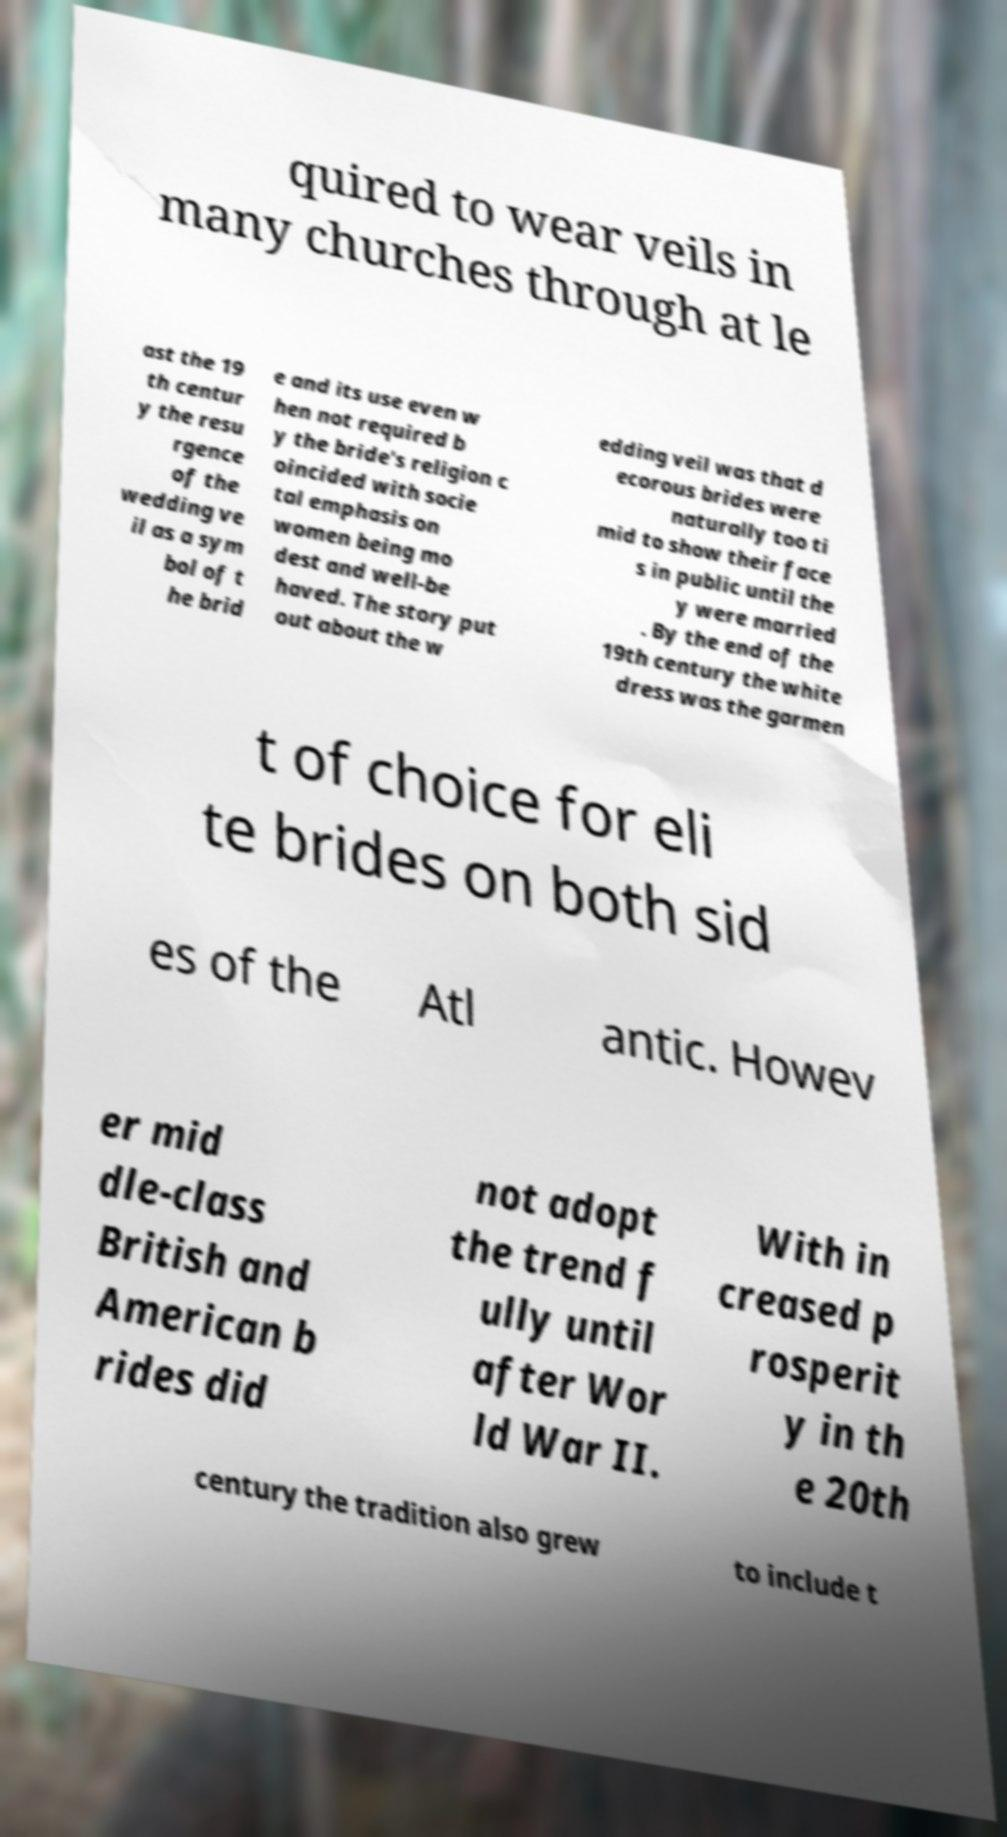For documentation purposes, I need the text within this image transcribed. Could you provide that? quired to wear veils in many churches through at le ast the 19 th centur y the resu rgence of the wedding ve il as a sym bol of t he brid e and its use even w hen not required b y the bride's religion c oincided with socie tal emphasis on women being mo dest and well-be haved. The story put out about the w edding veil was that d ecorous brides were naturally too ti mid to show their face s in public until the y were married . By the end of the 19th century the white dress was the garmen t of choice for eli te brides on both sid es of the Atl antic. Howev er mid dle-class British and American b rides did not adopt the trend f ully until after Wor ld War II. With in creased p rosperit y in th e 20th century the tradition also grew to include t 